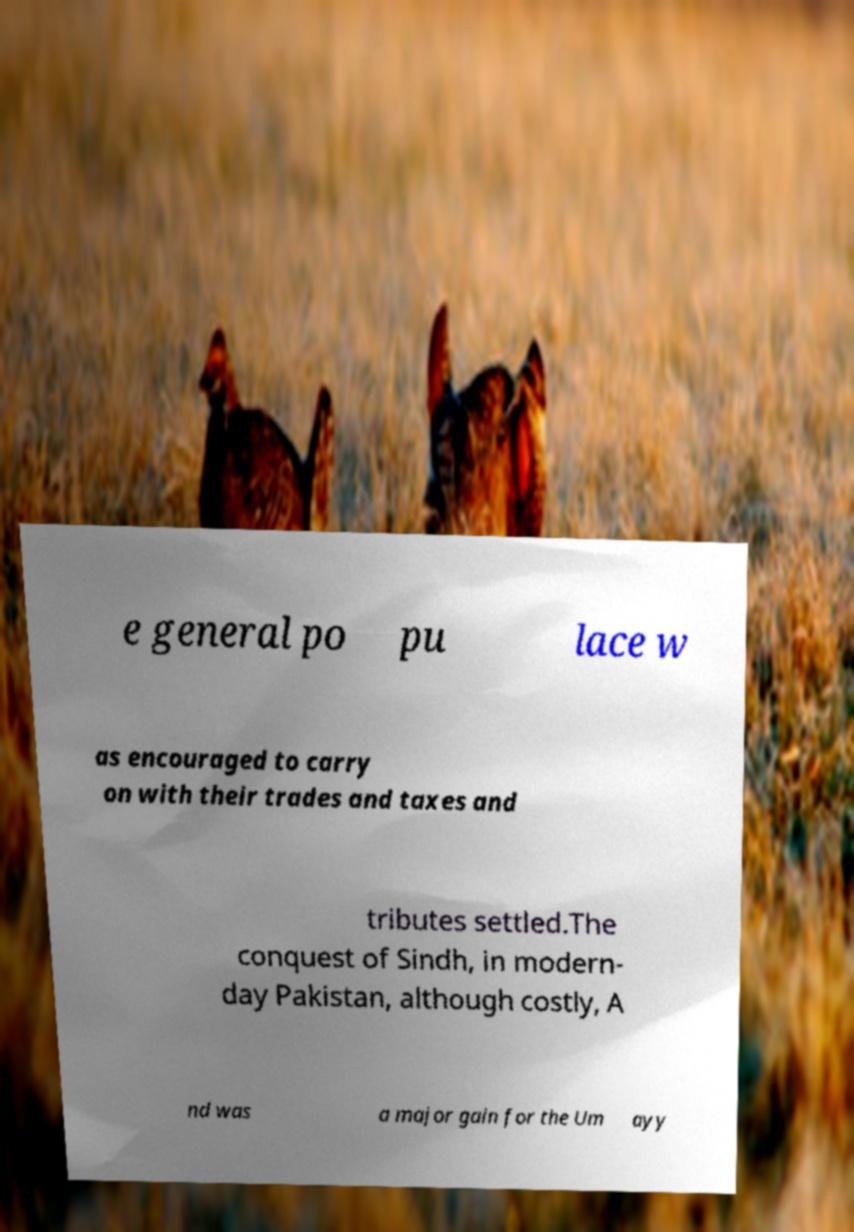Please read and relay the text visible in this image. What does it say? e general po pu lace w as encouraged to carry on with their trades and taxes and tributes settled.The conquest of Sindh, in modern- day Pakistan, although costly, A nd was a major gain for the Um ayy 